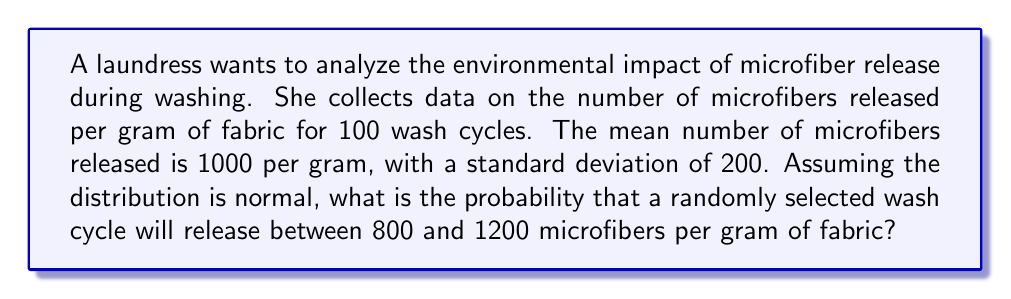Teach me how to tackle this problem. To solve this problem, we'll use the properties of the normal distribution and the concept of z-scores.

Step 1: Identify the given information
- Mean (μ) = 1000 microfibers/gram
- Standard deviation (σ) = 200 microfibers/gram
- We want to find P(800 < X < 1200)

Step 2: Calculate the z-scores for the lower and upper bounds
z-score formula: $z = \frac{x - \mu}{\sigma}$

For x = 800: $z_1 = \frac{800 - 1000}{200} = -1$
For x = 1200: $z_2 = \frac{1200 - 1000}{200} = 1$

Step 3: Use the standard normal distribution table or a calculator to find the area between these z-scores

The probability is equal to the area between z = -1 and z = 1 in a standard normal distribution.

This can be calculated as:
P(-1 < Z < 1) = P(Z < 1) - P(Z < -1)
              = 0.8413 - 0.1587
              = 0.6826

Step 4: Convert to percentage
0.6826 * 100 = 68.26%

Therefore, the probability that a randomly selected wash cycle will release between 800 and 1200 microfibers per gram of fabric is approximately 68.26%.
Answer: 68.26% 